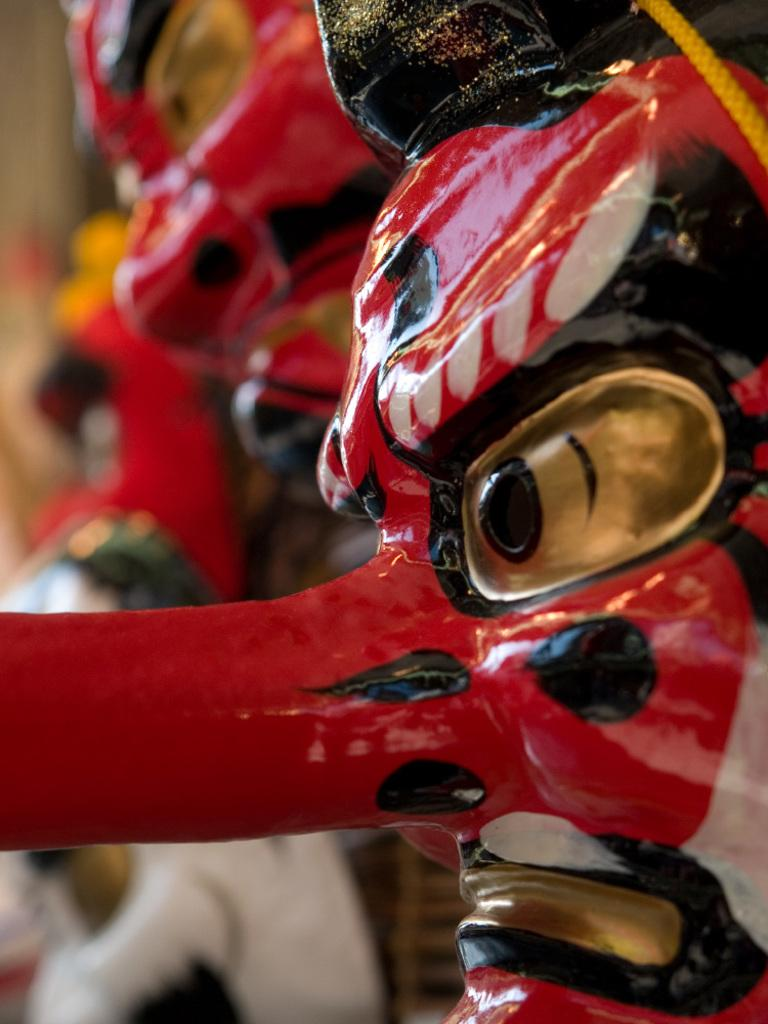What is the main subject of the image? The main subject of the image is a face mask. Can you describe the face mask in the image? The face mask is the main focus of the image. Are there any other masks visible in the image? Yes, there are other masks visible in the background of the image. What type of stove can be seen in the image? There is no stove present in the image; it features a face mask and other masks in the background. How many flies are visible on the face mask in the image? There are no flies visible on the face mask or in the image. 